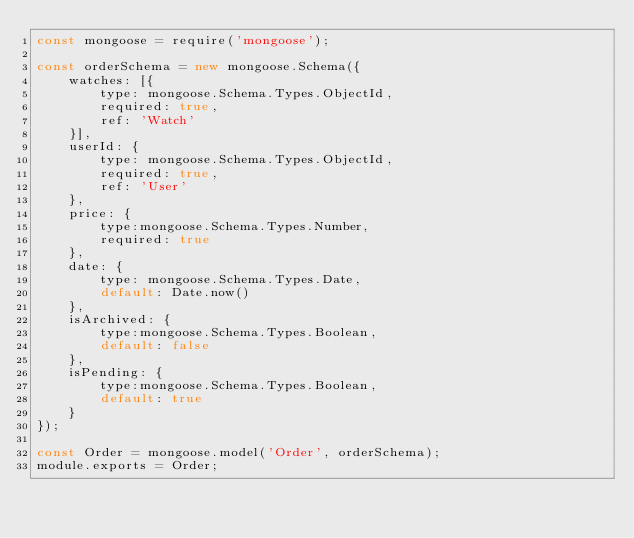Convert code to text. <code><loc_0><loc_0><loc_500><loc_500><_JavaScript_>const mongoose = require('mongoose');

const orderSchema = new mongoose.Schema({
    watches: [{
        type: mongoose.Schema.Types.ObjectId,
        required: true,
        ref: 'Watch'
    }],
    userId: {
        type: mongoose.Schema.Types.ObjectId,
        required: true,
        ref: 'User'
    },
    price: {
        type:mongoose.Schema.Types.Number,
        required: true
    },
    date: {
        type: mongoose.Schema.Types.Date,
        default: Date.now()
    },
    isArchived: {
        type:mongoose.Schema.Types.Boolean,
        default: false
    },
    isPending: {
        type:mongoose.Schema.Types.Boolean,
        default: true
    }
});

const Order = mongoose.model('Order', orderSchema);
module.exports = Order;</code> 